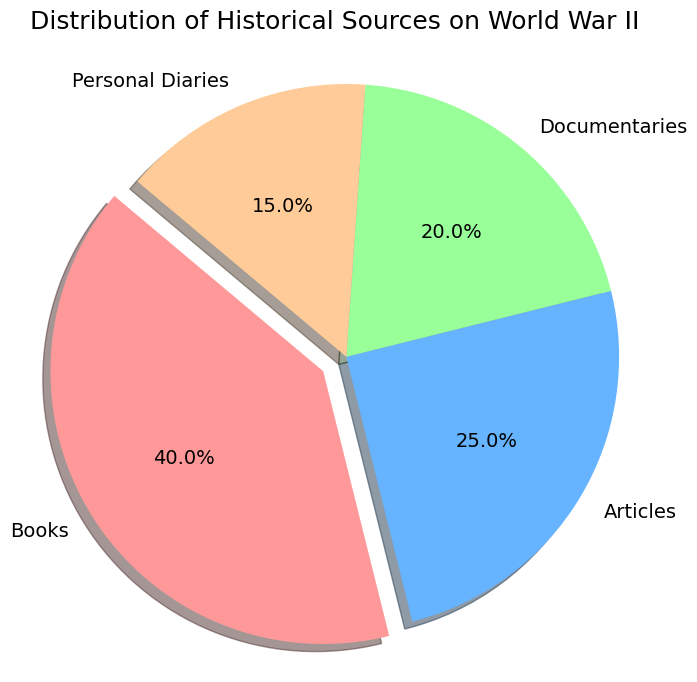What is the largest category in the distribution of historical sources on World War II? The figure shows four categories: Books, Articles, Documentaries, and Personal Diaries. The largest wedge in the pie chart represents Books, with the percentage label of 40%.
Answer: Books Which segment is smaller, Documentaries or Personal Diaries? Comparing the two slices of the pie chart, Documentaries have 20% and Personal Diaries have 15%. Since 15% is smaller than 20%, Personal Diaries represent the smaller segment.
Answer: Personal Diaries What is the difference in percentage between Articles and Documentaries? Articles comprise 25% of the sources, while Documentaries make up 20% of the sources. The difference in percentage is calculated as 25% - 20%, which equals 5%.
Answer: 5% Which category is represented by the red segment? Observing the color-coded segments in the pie chart, the red segment is associated with the label Books, which also has the largest percentage of 40%.
Answer: Books What is the total percentage of Books and Articles combined? The pie chart shows Books at 40% and Articles at 25%. Adding these percentages together gives 40% + 25% = 65%.
Answer: 65% How much larger is the percentage of Books compared to Personal Diaries? Books have 40% and Personal Diaries have 15%. The difference is calculated as 40% - 15%, which equals 25%.
Answer: 25% What proportion of the sources do Documentaries and Personal Diaries together represent? Documentaries account for 20% and Personal Diaries for 15%. Summing these percentages results in 20% + 15% = 35%.
Answer: 35% Which source has the smallest share, and what is its percentage? Among the categories, Personal Diaries have the smallest share with a percentage of 15%, as indicated by the smallest wedge in the pie chart.
Answer: Personal Diaries, 15% In the pie chart, which category closely follows Books in terms of percentage? Books lead with 40%. The next largest category is Articles, which is represented by 25%.
Answer: Articles 